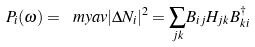<formula> <loc_0><loc_0><loc_500><loc_500>P _ { i } ( \omega ) = \ m y a v { | \Delta N _ { i } | ^ { 2 } } = { \sum _ { j k } } B _ { i j } H _ { j k } B _ { k i } ^ { \dag }</formula> 